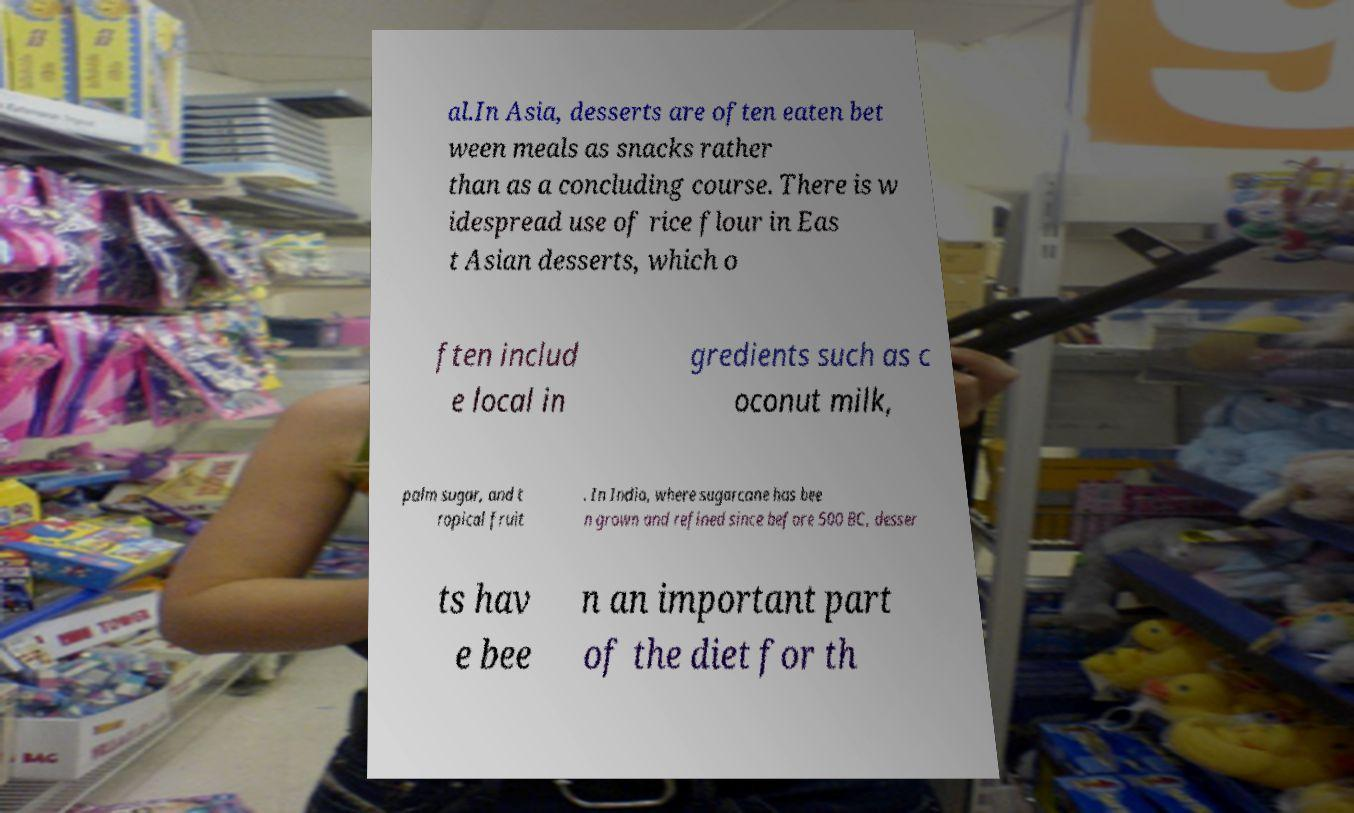Can you read and provide the text displayed in the image?This photo seems to have some interesting text. Can you extract and type it out for me? al.In Asia, desserts are often eaten bet ween meals as snacks rather than as a concluding course. There is w idespread use of rice flour in Eas t Asian desserts, which o ften includ e local in gredients such as c oconut milk, palm sugar, and t ropical fruit . In India, where sugarcane has bee n grown and refined since before 500 BC, desser ts hav e bee n an important part of the diet for th 